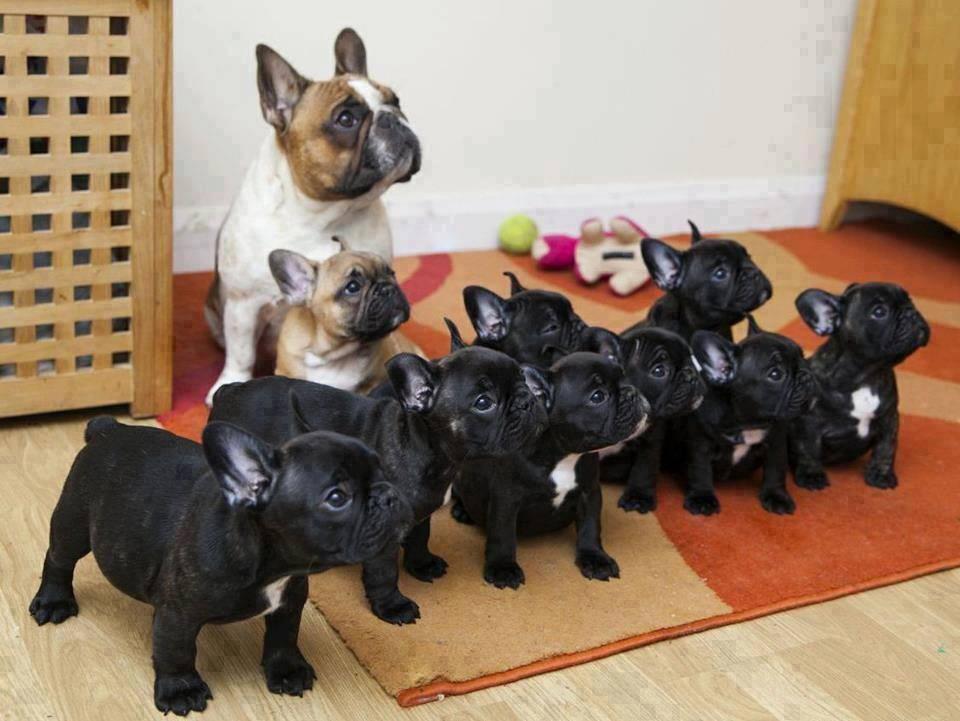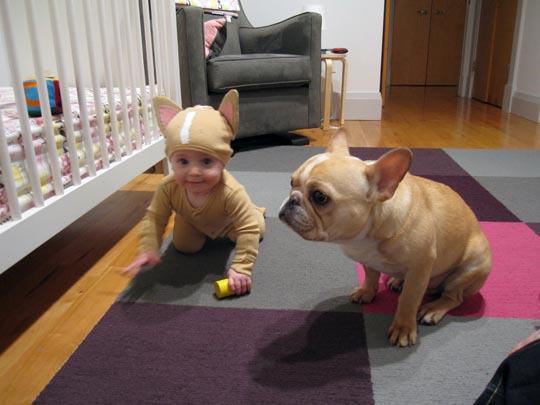The first image is the image on the left, the second image is the image on the right. Assess this claim about the two images: "A human is at least partially visible in the image on the right.". Correct or not? Answer yes or no. Yes. 